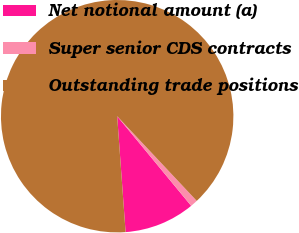Convert chart to OTSL. <chart><loc_0><loc_0><loc_500><loc_500><pie_chart><fcel>Net notional amount (a)<fcel>Super senior CDS contracts<fcel>Outstanding trade positions<nl><fcel>9.83%<fcel>1.02%<fcel>89.15%<nl></chart> 